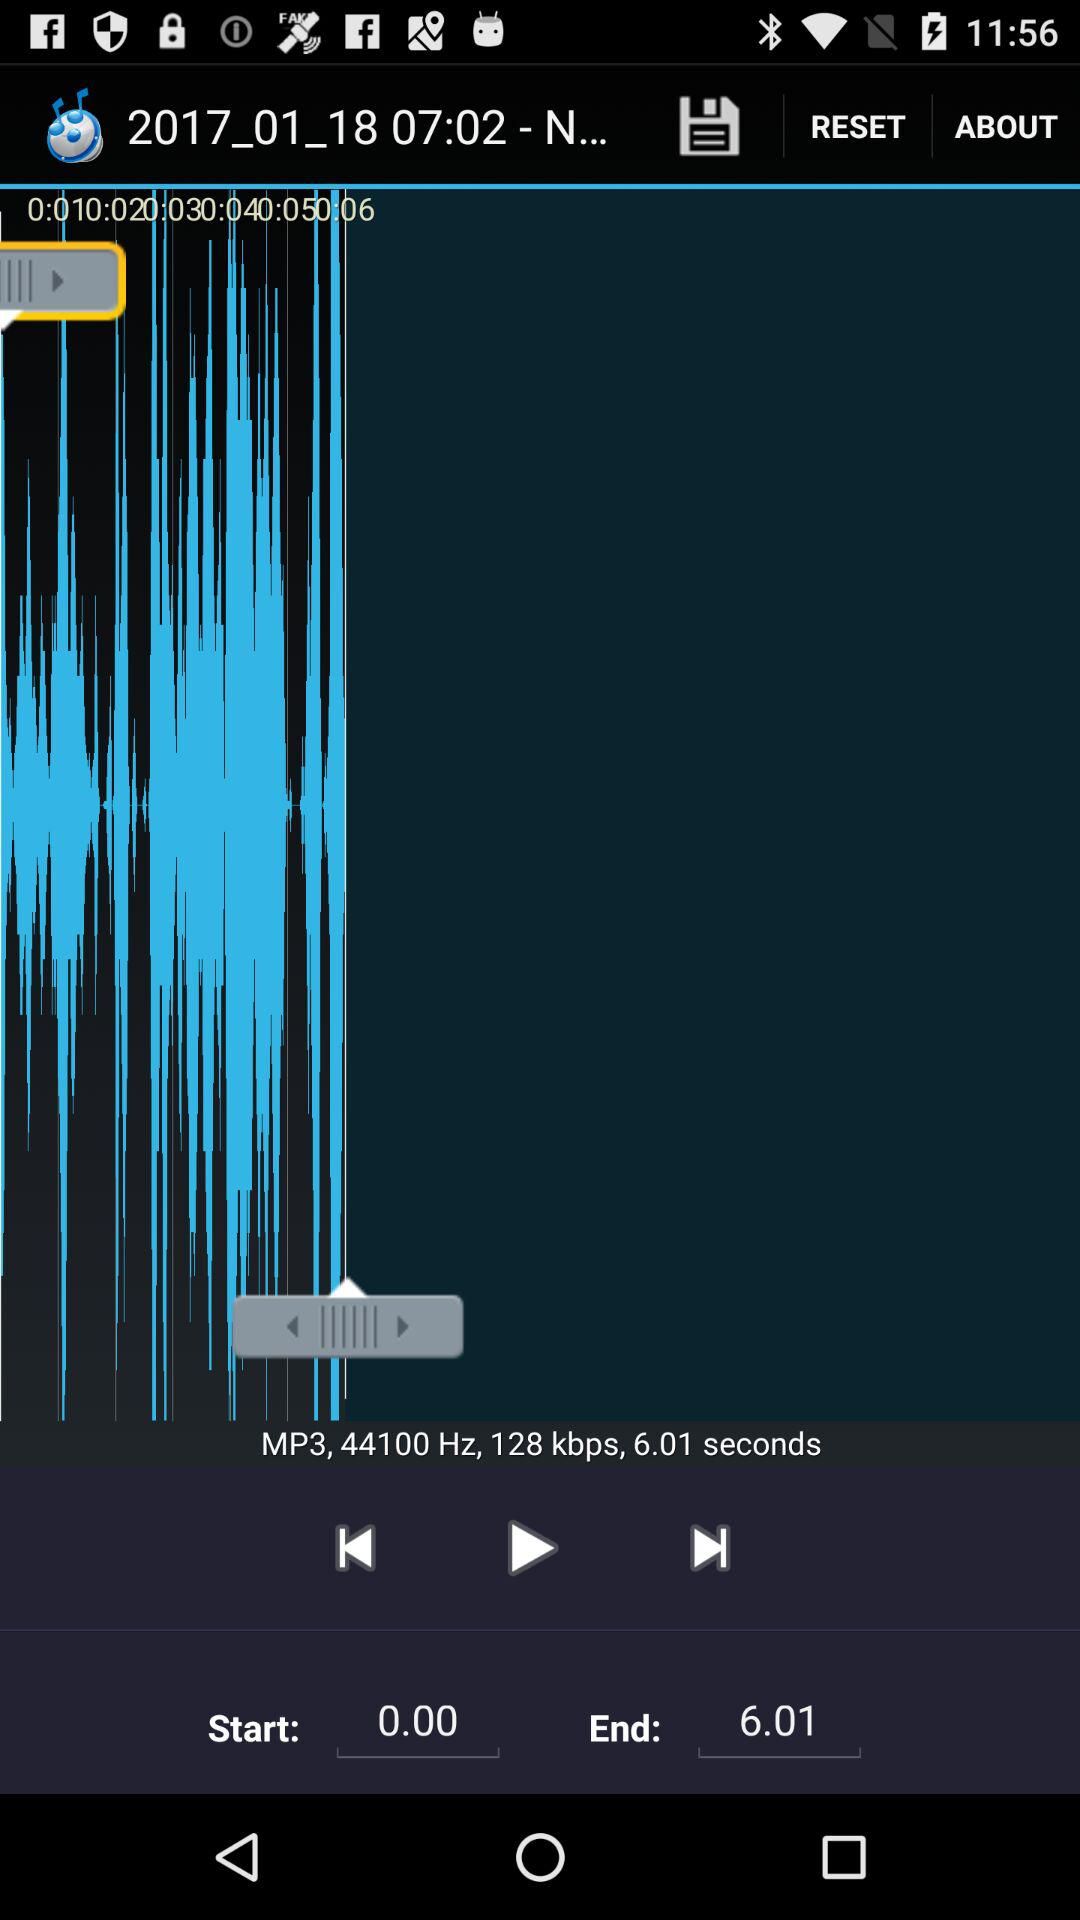How many seconds does the audio file last?
Answer the question using a single word or phrase. 6.01 